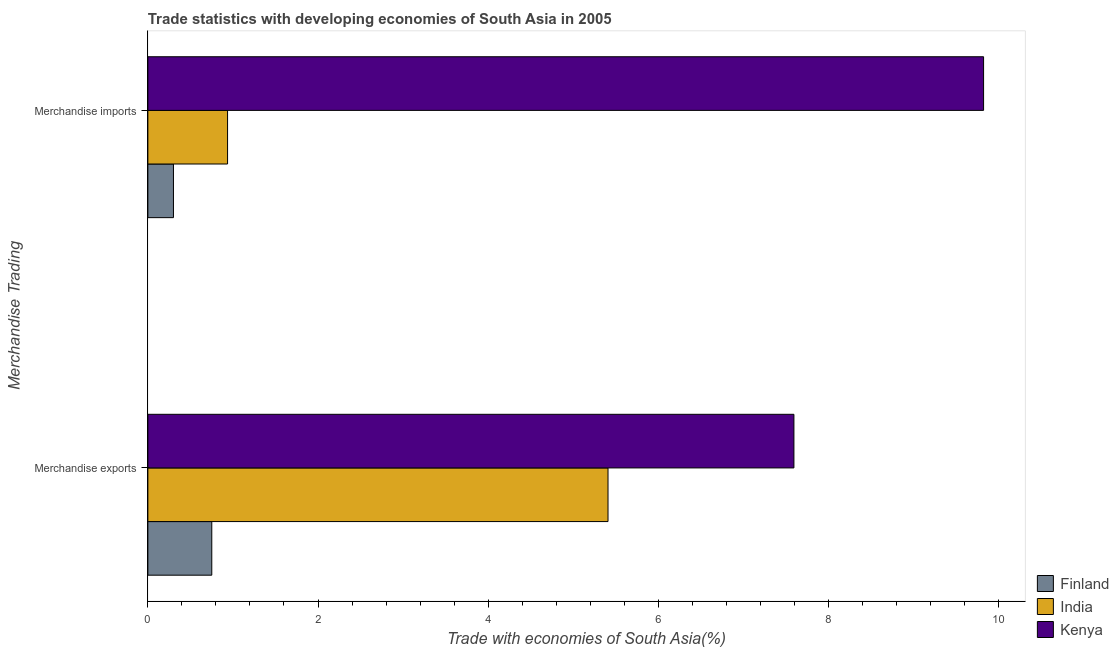How many groups of bars are there?
Ensure brevity in your answer.  2. Are the number of bars per tick equal to the number of legend labels?
Your answer should be compact. Yes. How many bars are there on the 1st tick from the top?
Ensure brevity in your answer.  3. How many bars are there on the 2nd tick from the bottom?
Keep it short and to the point. 3. What is the merchandise imports in India?
Your answer should be very brief. 0.94. Across all countries, what is the maximum merchandise exports?
Your answer should be compact. 7.6. Across all countries, what is the minimum merchandise imports?
Your response must be concise. 0.3. In which country was the merchandise imports maximum?
Ensure brevity in your answer.  Kenya. In which country was the merchandise exports minimum?
Make the answer very short. Finland. What is the total merchandise imports in the graph?
Your answer should be very brief. 11.06. What is the difference between the merchandise imports in Kenya and that in Finland?
Make the answer very short. 9.52. What is the difference between the merchandise imports in India and the merchandise exports in Finland?
Provide a short and direct response. 0.19. What is the average merchandise exports per country?
Make the answer very short. 4.59. What is the difference between the merchandise imports and merchandise exports in Kenya?
Your answer should be very brief. 2.23. What is the ratio of the merchandise exports in Kenya to that in India?
Keep it short and to the point. 1.4. What does the 3rd bar from the bottom in Merchandise exports represents?
Your answer should be very brief. Kenya. How many bars are there?
Your response must be concise. 6. Are all the bars in the graph horizontal?
Offer a very short reply. Yes. What is the difference between two consecutive major ticks on the X-axis?
Ensure brevity in your answer.  2. Does the graph contain grids?
Your response must be concise. No. How many legend labels are there?
Make the answer very short. 3. What is the title of the graph?
Offer a terse response. Trade statistics with developing economies of South Asia in 2005. What is the label or title of the X-axis?
Give a very brief answer. Trade with economies of South Asia(%). What is the label or title of the Y-axis?
Your answer should be compact. Merchandise Trading. What is the Trade with economies of South Asia(%) in Finland in Merchandise exports?
Offer a terse response. 0.75. What is the Trade with economies of South Asia(%) in India in Merchandise exports?
Keep it short and to the point. 5.41. What is the Trade with economies of South Asia(%) of Kenya in Merchandise exports?
Ensure brevity in your answer.  7.6. What is the Trade with economies of South Asia(%) in Finland in Merchandise imports?
Provide a short and direct response. 0.3. What is the Trade with economies of South Asia(%) in India in Merchandise imports?
Make the answer very short. 0.94. What is the Trade with economies of South Asia(%) of Kenya in Merchandise imports?
Give a very brief answer. 9.82. Across all Merchandise Trading, what is the maximum Trade with economies of South Asia(%) of Finland?
Your answer should be compact. 0.75. Across all Merchandise Trading, what is the maximum Trade with economies of South Asia(%) in India?
Keep it short and to the point. 5.41. Across all Merchandise Trading, what is the maximum Trade with economies of South Asia(%) of Kenya?
Keep it short and to the point. 9.82. Across all Merchandise Trading, what is the minimum Trade with economies of South Asia(%) in Finland?
Your answer should be compact. 0.3. Across all Merchandise Trading, what is the minimum Trade with economies of South Asia(%) of India?
Keep it short and to the point. 0.94. Across all Merchandise Trading, what is the minimum Trade with economies of South Asia(%) in Kenya?
Your response must be concise. 7.6. What is the total Trade with economies of South Asia(%) of Finland in the graph?
Ensure brevity in your answer.  1.05. What is the total Trade with economies of South Asia(%) in India in the graph?
Keep it short and to the point. 6.35. What is the total Trade with economies of South Asia(%) of Kenya in the graph?
Your answer should be compact. 17.42. What is the difference between the Trade with economies of South Asia(%) of Finland in Merchandise exports and that in Merchandise imports?
Give a very brief answer. 0.45. What is the difference between the Trade with economies of South Asia(%) in India in Merchandise exports and that in Merchandise imports?
Keep it short and to the point. 4.47. What is the difference between the Trade with economies of South Asia(%) of Kenya in Merchandise exports and that in Merchandise imports?
Your response must be concise. -2.23. What is the difference between the Trade with economies of South Asia(%) of Finland in Merchandise exports and the Trade with economies of South Asia(%) of India in Merchandise imports?
Your response must be concise. -0.19. What is the difference between the Trade with economies of South Asia(%) of Finland in Merchandise exports and the Trade with economies of South Asia(%) of Kenya in Merchandise imports?
Keep it short and to the point. -9.07. What is the difference between the Trade with economies of South Asia(%) of India in Merchandise exports and the Trade with economies of South Asia(%) of Kenya in Merchandise imports?
Provide a succinct answer. -4.42. What is the average Trade with economies of South Asia(%) in Finland per Merchandise Trading?
Offer a very short reply. 0.53. What is the average Trade with economies of South Asia(%) of India per Merchandise Trading?
Your answer should be compact. 3.17. What is the average Trade with economies of South Asia(%) of Kenya per Merchandise Trading?
Your answer should be very brief. 8.71. What is the difference between the Trade with economies of South Asia(%) in Finland and Trade with economies of South Asia(%) in India in Merchandise exports?
Offer a very short reply. -4.66. What is the difference between the Trade with economies of South Asia(%) in Finland and Trade with economies of South Asia(%) in Kenya in Merchandise exports?
Your response must be concise. -6.84. What is the difference between the Trade with economies of South Asia(%) in India and Trade with economies of South Asia(%) in Kenya in Merchandise exports?
Offer a very short reply. -2.19. What is the difference between the Trade with economies of South Asia(%) in Finland and Trade with economies of South Asia(%) in India in Merchandise imports?
Your answer should be compact. -0.64. What is the difference between the Trade with economies of South Asia(%) of Finland and Trade with economies of South Asia(%) of Kenya in Merchandise imports?
Your response must be concise. -9.52. What is the difference between the Trade with economies of South Asia(%) in India and Trade with economies of South Asia(%) in Kenya in Merchandise imports?
Keep it short and to the point. -8.89. What is the ratio of the Trade with economies of South Asia(%) of Finland in Merchandise exports to that in Merchandise imports?
Your response must be concise. 2.5. What is the ratio of the Trade with economies of South Asia(%) of India in Merchandise exports to that in Merchandise imports?
Keep it short and to the point. 5.77. What is the ratio of the Trade with economies of South Asia(%) of Kenya in Merchandise exports to that in Merchandise imports?
Offer a very short reply. 0.77. What is the difference between the highest and the second highest Trade with economies of South Asia(%) of Finland?
Offer a very short reply. 0.45. What is the difference between the highest and the second highest Trade with economies of South Asia(%) in India?
Keep it short and to the point. 4.47. What is the difference between the highest and the second highest Trade with economies of South Asia(%) in Kenya?
Offer a terse response. 2.23. What is the difference between the highest and the lowest Trade with economies of South Asia(%) of Finland?
Offer a very short reply. 0.45. What is the difference between the highest and the lowest Trade with economies of South Asia(%) of India?
Keep it short and to the point. 4.47. What is the difference between the highest and the lowest Trade with economies of South Asia(%) in Kenya?
Provide a succinct answer. 2.23. 